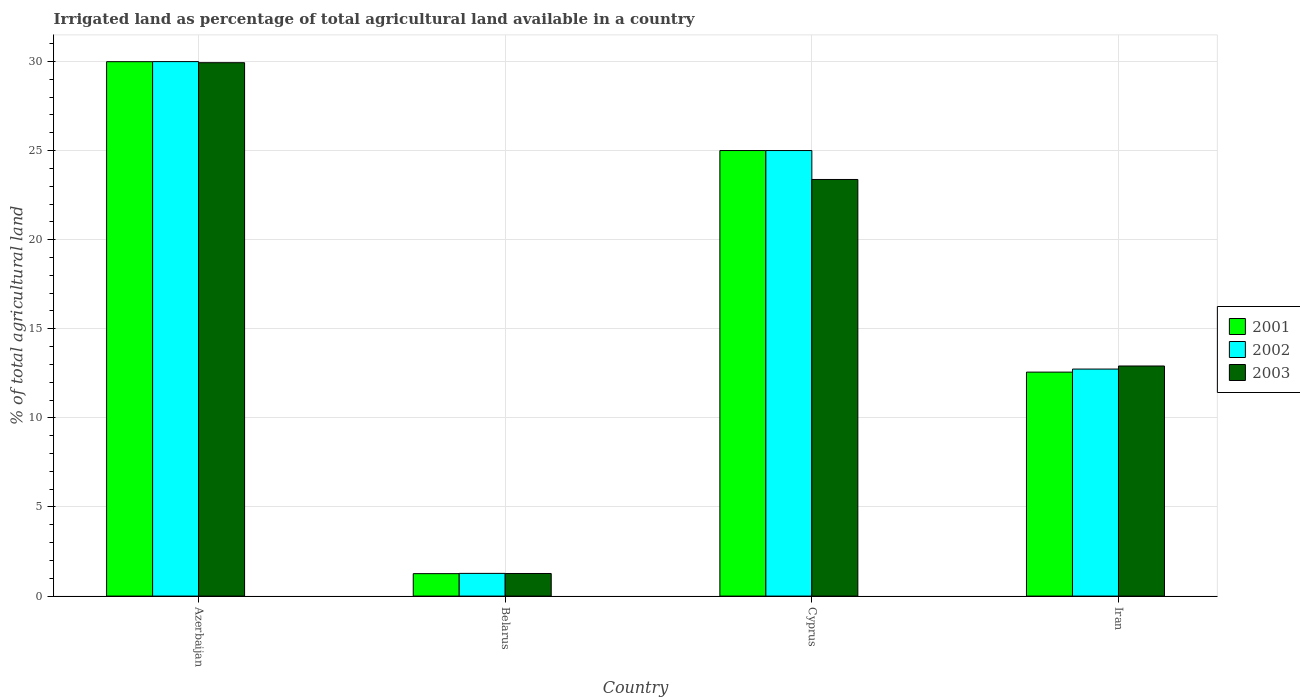How many different coloured bars are there?
Your answer should be compact. 3. How many groups of bars are there?
Make the answer very short. 4. Are the number of bars on each tick of the X-axis equal?
Offer a terse response. Yes. How many bars are there on the 2nd tick from the right?
Your response must be concise. 3. What is the label of the 1st group of bars from the left?
Give a very brief answer. Azerbaijan. In how many cases, is the number of bars for a given country not equal to the number of legend labels?
Give a very brief answer. 0. What is the percentage of irrigated land in 2001 in Iran?
Give a very brief answer. 12.57. Across all countries, what is the maximum percentage of irrigated land in 2001?
Give a very brief answer. 29.99. Across all countries, what is the minimum percentage of irrigated land in 2003?
Provide a succinct answer. 1.27. In which country was the percentage of irrigated land in 2002 maximum?
Give a very brief answer. Azerbaijan. In which country was the percentage of irrigated land in 2002 minimum?
Offer a very short reply. Belarus. What is the total percentage of irrigated land in 2002 in the graph?
Offer a terse response. 69. What is the difference between the percentage of irrigated land in 2002 in Azerbaijan and that in Cyprus?
Ensure brevity in your answer.  4.99. What is the difference between the percentage of irrigated land in 2003 in Iran and the percentage of irrigated land in 2001 in Belarus?
Keep it short and to the point. 11.65. What is the average percentage of irrigated land in 2001 per country?
Make the answer very short. 17.2. What is the difference between the percentage of irrigated land of/in 2001 and percentage of irrigated land of/in 2003 in Cyprus?
Offer a terse response. 1.62. What is the ratio of the percentage of irrigated land in 2002 in Belarus to that in Cyprus?
Your answer should be compact. 0.05. What is the difference between the highest and the second highest percentage of irrigated land in 2003?
Offer a terse response. -17.02. What is the difference between the highest and the lowest percentage of irrigated land in 2001?
Give a very brief answer. 28.73. Is the sum of the percentage of irrigated land in 2003 in Cyprus and Iran greater than the maximum percentage of irrigated land in 2002 across all countries?
Keep it short and to the point. Yes. Is it the case that in every country, the sum of the percentage of irrigated land in 2001 and percentage of irrigated land in 2003 is greater than the percentage of irrigated land in 2002?
Your response must be concise. Yes. How many countries are there in the graph?
Provide a short and direct response. 4. Are the values on the major ticks of Y-axis written in scientific E-notation?
Make the answer very short. No. How many legend labels are there?
Ensure brevity in your answer.  3. How are the legend labels stacked?
Ensure brevity in your answer.  Vertical. What is the title of the graph?
Give a very brief answer. Irrigated land as percentage of total agricultural land available in a country. Does "1970" appear as one of the legend labels in the graph?
Offer a very short reply. No. What is the label or title of the X-axis?
Offer a terse response. Country. What is the label or title of the Y-axis?
Provide a short and direct response. % of total agricultural land. What is the % of total agricultural land of 2001 in Azerbaijan?
Offer a very short reply. 29.99. What is the % of total agricultural land of 2002 in Azerbaijan?
Keep it short and to the point. 29.99. What is the % of total agricultural land of 2003 in Azerbaijan?
Ensure brevity in your answer.  29.93. What is the % of total agricultural land in 2001 in Belarus?
Offer a very short reply. 1.26. What is the % of total agricultural land of 2002 in Belarus?
Your response must be concise. 1.27. What is the % of total agricultural land in 2003 in Belarus?
Provide a short and direct response. 1.27. What is the % of total agricultural land of 2002 in Cyprus?
Your answer should be compact. 25. What is the % of total agricultural land of 2003 in Cyprus?
Provide a short and direct response. 23.38. What is the % of total agricultural land of 2001 in Iran?
Give a very brief answer. 12.57. What is the % of total agricultural land in 2002 in Iran?
Provide a succinct answer. 12.74. What is the % of total agricultural land in 2003 in Iran?
Your response must be concise. 12.91. Across all countries, what is the maximum % of total agricultural land of 2001?
Your answer should be very brief. 29.99. Across all countries, what is the maximum % of total agricultural land in 2002?
Make the answer very short. 29.99. Across all countries, what is the maximum % of total agricultural land in 2003?
Provide a succinct answer. 29.93. Across all countries, what is the minimum % of total agricultural land in 2001?
Give a very brief answer. 1.26. Across all countries, what is the minimum % of total agricultural land in 2002?
Offer a very short reply. 1.27. Across all countries, what is the minimum % of total agricultural land in 2003?
Offer a very short reply. 1.27. What is the total % of total agricultural land of 2001 in the graph?
Provide a succinct answer. 68.81. What is the total % of total agricultural land in 2002 in the graph?
Make the answer very short. 69. What is the total % of total agricultural land in 2003 in the graph?
Make the answer very short. 67.48. What is the difference between the % of total agricultural land of 2001 in Azerbaijan and that in Belarus?
Your answer should be very brief. 28.73. What is the difference between the % of total agricultural land of 2002 in Azerbaijan and that in Belarus?
Give a very brief answer. 28.72. What is the difference between the % of total agricultural land in 2003 in Azerbaijan and that in Belarus?
Keep it short and to the point. 28.66. What is the difference between the % of total agricultural land of 2001 in Azerbaijan and that in Cyprus?
Offer a very short reply. 4.99. What is the difference between the % of total agricultural land of 2002 in Azerbaijan and that in Cyprus?
Make the answer very short. 4.99. What is the difference between the % of total agricultural land in 2003 in Azerbaijan and that in Cyprus?
Make the answer very short. 6.55. What is the difference between the % of total agricultural land in 2001 in Azerbaijan and that in Iran?
Make the answer very short. 17.42. What is the difference between the % of total agricultural land of 2002 in Azerbaijan and that in Iran?
Your response must be concise. 17.25. What is the difference between the % of total agricultural land of 2003 in Azerbaijan and that in Iran?
Offer a very short reply. 17.02. What is the difference between the % of total agricultural land in 2001 in Belarus and that in Cyprus?
Your response must be concise. -23.74. What is the difference between the % of total agricultural land in 2002 in Belarus and that in Cyprus?
Ensure brevity in your answer.  -23.73. What is the difference between the % of total agricultural land of 2003 in Belarus and that in Cyprus?
Ensure brevity in your answer.  -22.11. What is the difference between the % of total agricultural land of 2001 in Belarus and that in Iran?
Your response must be concise. -11.31. What is the difference between the % of total agricultural land of 2002 in Belarus and that in Iran?
Make the answer very short. -11.46. What is the difference between the % of total agricultural land of 2003 in Belarus and that in Iran?
Your answer should be compact. -11.64. What is the difference between the % of total agricultural land of 2001 in Cyprus and that in Iran?
Make the answer very short. 12.43. What is the difference between the % of total agricultural land of 2002 in Cyprus and that in Iran?
Ensure brevity in your answer.  12.26. What is the difference between the % of total agricultural land in 2003 in Cyprus and that in Iran?
Provide a short and direct response. 10.47. What is the difference between the % of total agricultural land of 2001 in Azerbaijan and the % of total agricultural land of 2002 in Belarus?
Ensure brevity in your answer.  28.71. What is the difference between the % of total agricultural land in 2001 in Azerbaijan and the % of total agricultural land in 2003 in Belarus?
Keep it short and to the point. 28.72. What is the difference between the % of total agricultural land in 2002 in Azerbaijan and the % of total agricultural land in 2003 in Belarus?
Provide a short and direct response. 28.72. What is the difference between the % of total agricultural land in 2001 in Azerbaijan and the % of total agricultural land in 2002 in Cyprus?
Give a very brief answer. 4.99. What is the difference between the % of total agricultural land in 2001 in Azerbaijan and the % of total agricultural land in 2003 in Cyprus?
Ensure brevity in your answer.  6.61. What is the difference between the % of total agricultural land of 2002 in Azerbaijan and the % of total agricultural land of 2003 in Cyprus?
Offer a very short reply. 6.61. What is the difference between the % of total agricultural land in 2001 in Azerbaijan and the % of total agricultural land in 2002 in Iran?
Your answer should be compact. 17.25. What is the difference between the % of total agricultural land in 2001 in Azerbaijan and the % of total agricultural land in 2003 in Iran?
Make the answer very short. 17.08. What is the difference between the % of total agricultural land of 2002 in Azerbaijan and the % of total agricultural land of 2003 in Iran?
Give a very brief answer. 17.08. What is the difference between the % of total agricultural land of 2001 in Belarus and the % of total agricultural land of 2002 in Cyprus?
Offer a very short reply. -23.74. What is the difference between the % of total agricultural land in 2001 in Belarus and the % of total agricultural land in 2003 in Cyprus?
Keep it short and to the point. -22.12. What is the difference between the % of total agricultural land of 2002 in Belarus and the % of total agricultural land of 2003 in Cyprus?
Provide a short and direct response. -22.1. What is the difference between the % of total agricultural land of 2001 in Belarus and the % of total agricultural land of 2002 in Iran?
Give a very brief answer. -11.48. What is the difference between the % of total agricultural land of 2001 in Belarus and the % of total agricultural land of 2003 in Iran?
Offer a very short reply. -11.65. What is the difference between the % of total agricultural land in 2002 in Belarus and the % of total agricultural land in 2003 in Iran?
Offer a terse response. -11.64. What is the difference between the % of total agricultural land in 2001 in Cyprus and the % of total agricultural land in 2002 in Iran?
Offer a very short reply. 12.26. What is the difference between the % of total agricultural land of 2001 in Cyprus and the % of total agricultural land of 2003 in Iran?
Your answer should be very brief. 12.09. What is the difference between the % of total agricultural land of 2002 in Cyprus and the % of total agricultural land of 2003 in Iran?
Provide a short and direct response. 12.09. What is the average % of total agricultural land of 2001 per country?
Provide a short and direct response. 17.2. What is the average % of total agricultural land of 2002 per country?
Offer a very short reply. 17.25. What is the average % of total agricultural land in 2003 per country?
Ensure brevity in your answer.  16.87. What is the difference between the % of total agricultural land in 2001 and % of total agricultural land in 2002 in Azerbaijan?
Your response must be concise. -0. What is the difference between the % of total agricultural land in 2001 and % of total agricultural land in 2003 in Azerbaijan?
Give a very brief answer. 0.06. What is the difference between the % of total agricultural land of 2002 and % of total agricultural land of 2003 in Azerbaijan?
Provide a short and direct response. 0.06. What is the difference between the % of total agricultural land in 2001 and % of total agricultural land in 2002 in Belarus?
Make the answer very short. -0.01. What is the difference between the % of total agricultural land of 2001 and % of total agricultural land of 2003 in Belarus?
Offer a very short reply. -0.01. What is the difference between the % of total agricultural land of 2002 and % of total agricultural land of 2003 in Belarus?
Give a very brief answer. 0.01. What is the difference between the % of total agricultural land in 2001 and % of total agricultural land in 2003 in Cyprus?
Keep it short and to the point. 1.62. What is the difference between the % of total agricultural land of 2002 and % of total agricultural land of 2003 in Cyprus?
Offer a terse response. 1.62. What is the difference between the % of total agricultural land in 2001 and % of total agricultural land in 2002 in Iran?
Give a very brief answer. -0.17. What is the difference between the % of total agricultural land of 2001 and % of total agricultural land of 2003 in Iran?
Ensure brevity in your answer.  -0.34. What is the difference between the % of total agricultural land in 2002 and % of total agricultural land in 2003 in Iran?
Provide a short and direct response. -0.17. What is the ratio of the % of total agricultural land in 2001 in Azerbaijan to that in Belarus?
Provide a succinct answer. 23.8. What is the ratio of the % of total agricultural land of 2002 in Azerbaijan to that in Belarus?
Your response must be concise. 23.54. What is the ratio of the % of total agricultural land of 2003 in Azerbaijan to that in Belarus?
Offer a terse response. 23.59. What is the ratio of the % of total agricultural land in 2001 in Azerbaijan to that in Cyprus?
Provide a short and direct response. 1.2. What is the ratio of the % of total agricultural land in 2002 in Azerbaijan to that in Cyprus?
Ensure brevity in your answer.  1.2. What is the ratio of the % of total agricultural land of 2003 in Azerbaijan to that in Cyprus?
Offer a very short reply. 1.28. What is the ratio of the % of total agricultural land in 2001 in Azerbaijan to that in Iran?
Ensure brevity in your answer.  2.39. What is the ratio of the % of total agricultural land of 2002 in Azerbaijan to that in Iran?
Your answer should be very brief. 2.35. What is the ratio of the % of total agricultural land of 2003 in Azerbaijan to that in Iran?
Your answer should be very brief. 2.32. What is the ratio of the % of total agricultural land in 2001 in Belarus to that in Cyprus?
Provide a succinct answer. 0.05. What is the ratio of the % of total agricultural land of 2002 in Belarus to that in Cyprus?
Offer a very short reply. 0.05. What is the ratio of the % of total agricultural land of 2003 in Belarus to that in Cyprus?
Offer a very short reply. 0.05. What is the ratio of the % of total agricultural land of 2001 in Belarus to that in Iran?
Provide a short and direct response. 0.1. What is the ratio of the % of total agricultural land of 2003 in Belarus to that in Iran?
Offer a terse response. 0.1. What is the ratio of the % of total agricultural land in 2001 in Cyprus to that in Iran?
Your response must be concise. 1.99. What is the ratio of the % of total agricultural land in 2002 in Cyprus to that in Iran?
Ensure brevity in your answer.  1.96. What is the ratio of the % of total agricultural land in 2003 in Cyprus to that in Iran?
Your answer should be very brief. 1.81. What is the difference between the highest and the second highest % of total agricultural land in 2001?
Keep it short and to the point. 4.99. What is the difference between the highest and the second highest % of total agricultural land in 2002?
Provide a short and direct response. 4.99. What is the difference between the highest and the second highest % of total agricultural land of 2003?
Make the answer very short. 6.55. What is the difference between the highest and the lowest % of total agricultural land of 2001?
Give a very brief answer. 28.73. What is the difference between the highest and the lowest % of total agricultural land of 2002?
Offer a very short reply. 28.72. What is the difference between the highest and the lowest % of total agricultural land in 2003?
Your answer should be compact. 28.66. 